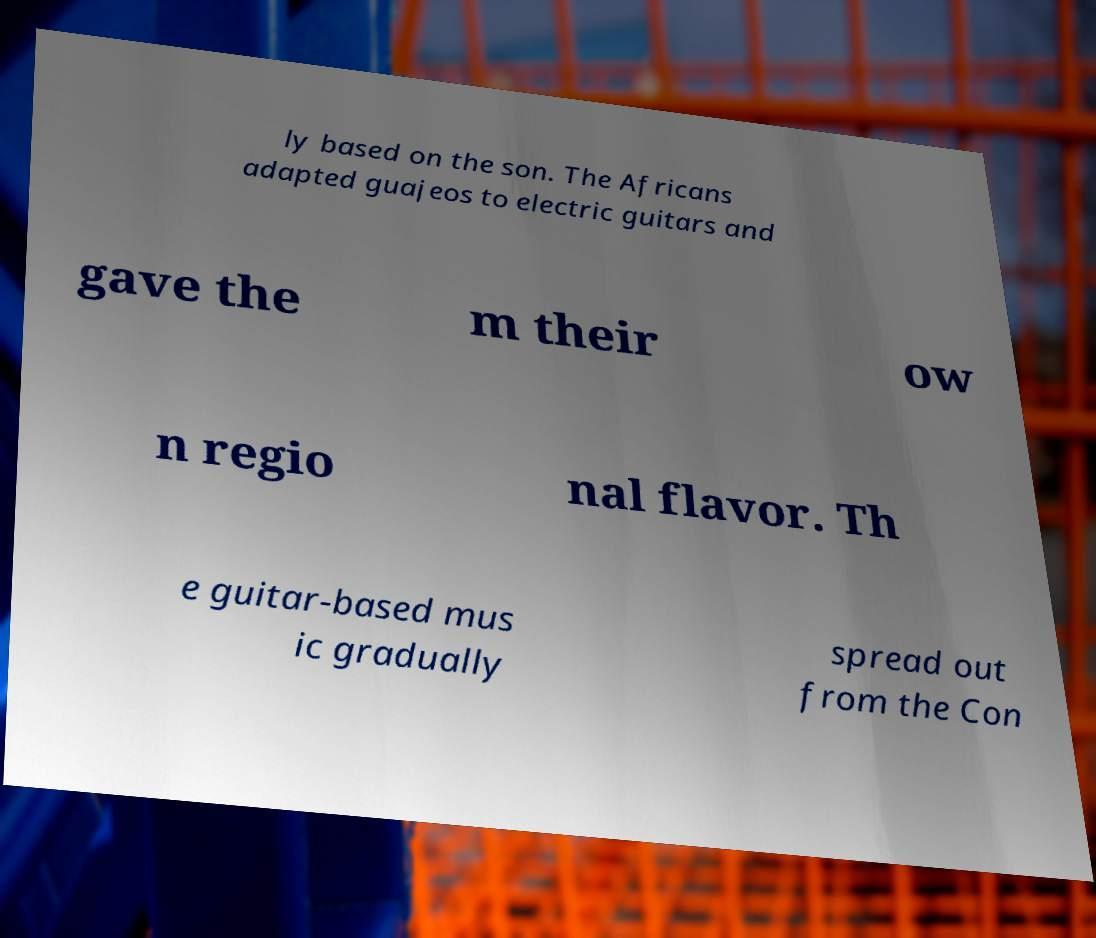I need the written content from this picture converted into text. Can you do that? ly based on the son. The Africans adapted guajeos to electric guitars and gave the m their ow n regio nal flavor. Th e guitar-based mus ic gradually spread out from the Con 